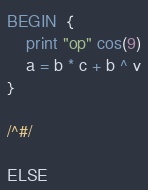Convert code to text. <code><loc_0><loc_0><loc_500><loc_500><_Awk_>BEGIN  {
	print "op" cos(9)
	a = b * c + b ^ v
}

/^#/

ELSE
</code> 